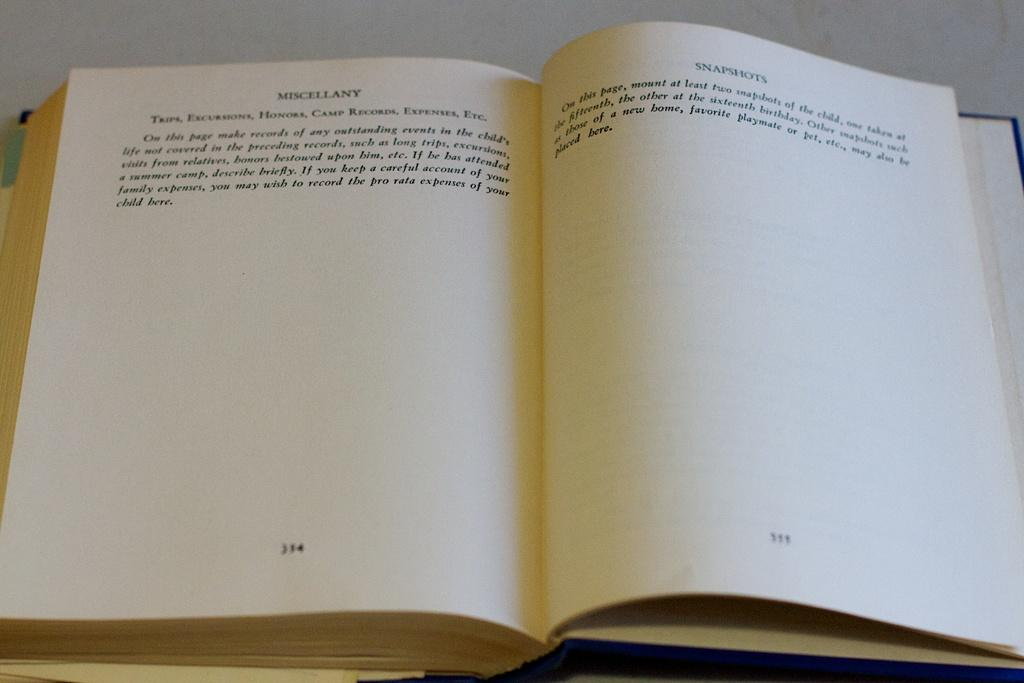<image>
Share a concise interpretation of the image provided. An open book with the word MISCELLANY at the top of one page 